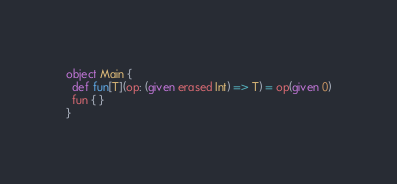<code> <loc_0><loc_0><loc_500><loc_500><_Scala_>object Main {
  def fun[T](op: (given erased Int) => T) = op(given 0)
  fun { }
}
</code> 